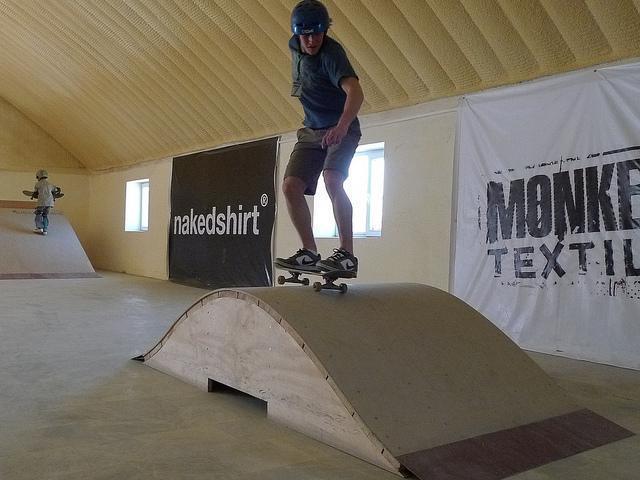How many skaters are there?
Give a very brief answer. 2. 